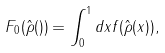Convert formula to latex. <formula><loc_0><loc_0><loc_500><loc_500>F _ { 0 } ( \hat { \rho } ( ) ) = \int _ { 0 } ^ { 1 } d x f ( \hat { \rho } ( x ) ) ,</formula> 